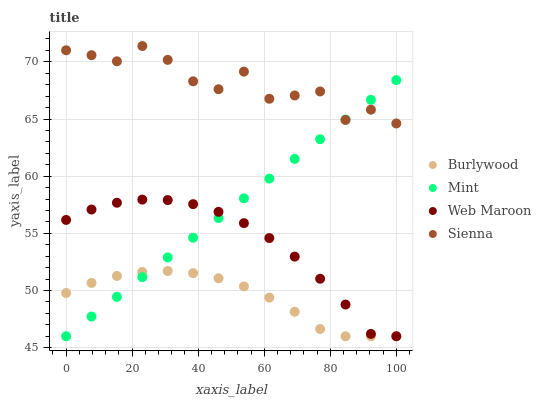Does Burlywood have the minimum area under the curve?
Answer yes or no. Yes. Does Sienna have the maximum area under the curve?
Answer yes or no. Yes. Does Web Maroon have the minimum area under the curve?
Answer yes or no. No. Does Web Maroon have the maximum area under the curve?
Answer yes or no. No. Is Mint the smoothest?
Answer yes or no. Yes. Is Sienna the roughest?
Answer yes or no. Yes. Is Web Maroon the smoothest?
Answer yes or no. No. Is Web Maroon the roughest?
Answer yes or no. No. Does Burlywood have the lowest value?
Answer yes or no. Yes. Does Sienna have the lowest value?
Answer yes or no. No. Does Sienna have the highest value?
Answer yes or no. Yes. Does Web Maroon have the highest value?
Answer yes or no. No. Is Web Maroon less than Sienna?
Answer yes or no. Yes. Is Sienna greater than Burlywood?
Answer yes or no. Yes. Does Sienna intersect Mint?
Answer yes or no. Yes. Is Sienna less than Mint?
Answer yes or no. No. Is Sienna greater than Mint?
Answer yes or no. No. Does Web Maroon intersect Sienna?
Answer yes or no. No. 